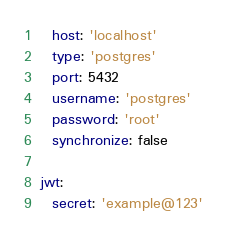<code> <loc_0><loc_0><loc_500><loc_500><_YAML_>  host: 'localhost'
  type: 'postgres'
  port: 5432
  username: 'postgres'
  password: 'root'
  synchronize: false

jwt:
  secret: 'example@123'
</code> 